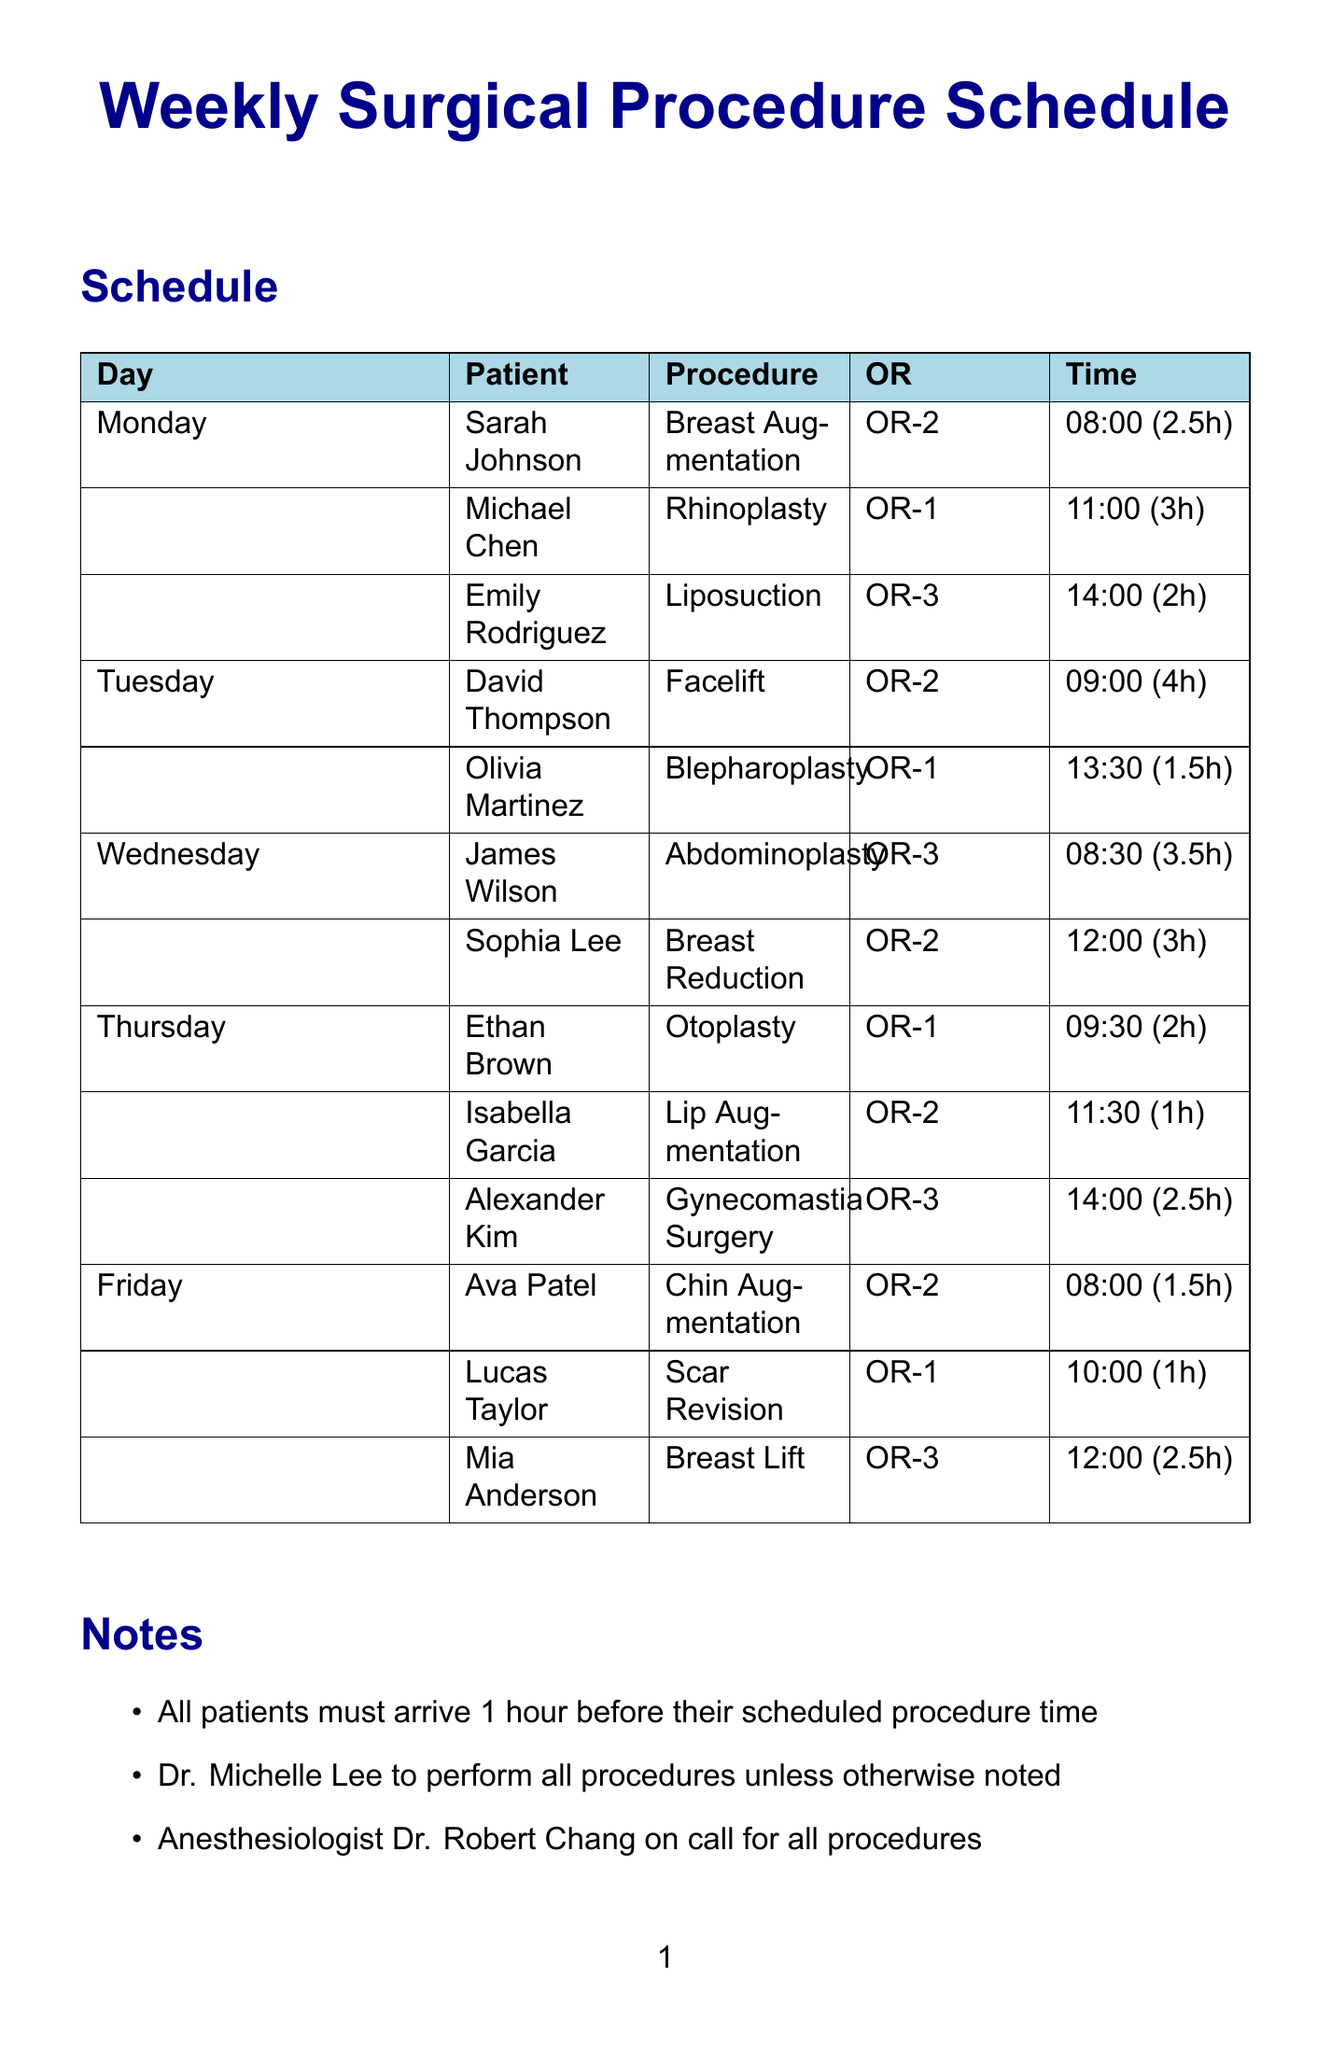What time is Sarah Johnson's surgery scheduled for? Sarah Johnson's surgery starts at 08:00 on Monday.
Answer: 08:00 How long is the procedure for David Thompson? David Thompson's facelift procedure is scheduled for 4 hours.
Answer: 4 hours Which operating room is used for Emily Rodriguez's Liposuction? Emily Rodriguez is assigned to operating room OR-3 for her procedure.
Answer: OR-3 Who is the anesthesiologist on call for all procedures? The anesthesiologist on call is Dr. Robert Chang.
Answer: Dr. Robert Chang What type of procedure does Alexander Kim have? Alexander Kim is scheduled for Gynecomastia Surgery.
Answer: Gynecomastia Surgery On which day is Mia Anderson's Breast Lift scheduled? Mia Anderson's Breast Lift is scheduled for Friday.
Answer: Friday What is the maximum duration of any procedure listed in the schedule? The longest procedure duration is 4 hours for David Thompson's facelift.
Answer: 4 hours What special feature does OR-2 have? OR-2 is equipped with a Robotic surgical assistant.
Answer: Robotic surgical assistant How many procedures are scheduled on Thursday? There are three procedures scheduled on Thursday.
Answer: three 